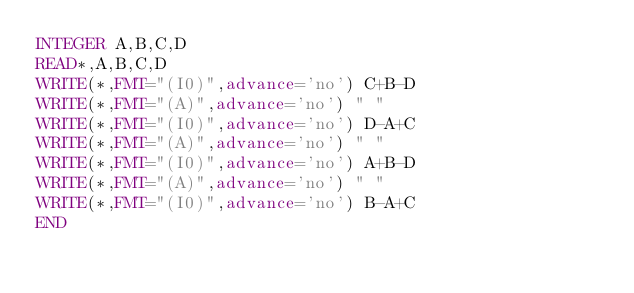Convert code to text. <code><loc_0><loc_0><loc_500><loc_500><_FORTRAN_>INTEGER A,B,C,D
READ*,A,B,C,D
WRITE(*,FMT="(I0)",advance='no') C+B-D
WRITE(*,FMT="(A)",advance='no') " "
WRITE(*,FMT="(I0)",advance='no') D-A+C
WRITE(*,FMT="(A)",advance='no') " "
WRITE(*,FMT="(I0)",advance='no') A+B-D
WRITE(*,FMT="(A)",advance='no') " "
WRITE(*,FMT="(I0)",advance='no') B-A+C
END</code> 